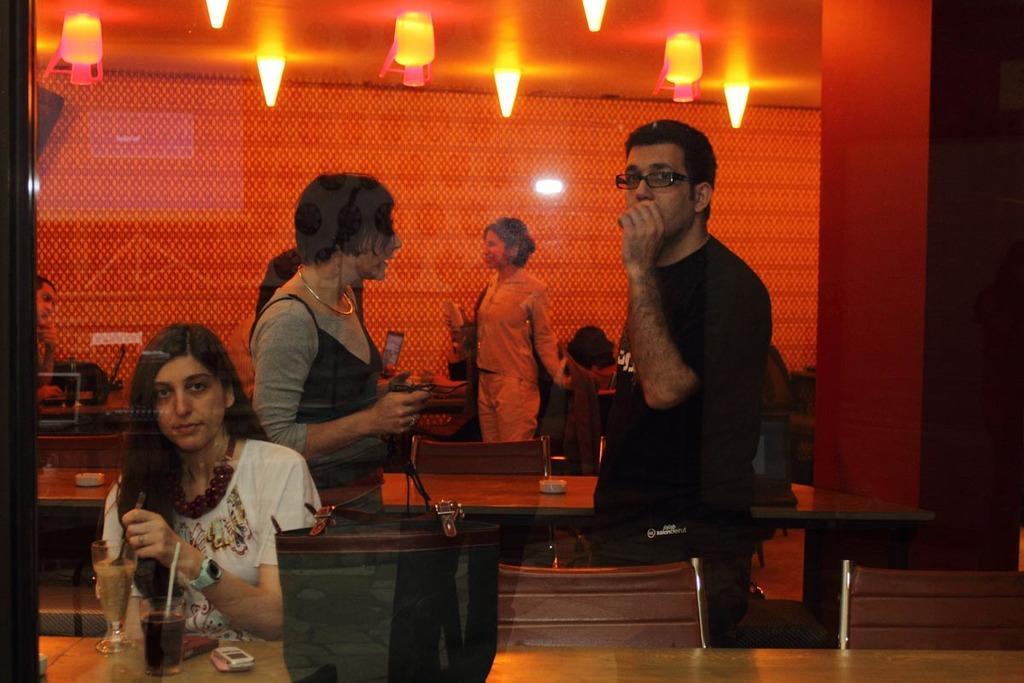Please provide a concise description of this image. This image is taken in a restaurant. In this image we can see a man and a woman standing. We can also see a woman sitting on the chair in front of the table and on the table we can see the glasses and also mobile phone and bag. In the background we can see the chairs, tables, laptop, bag and also some persons. We can also see the wall. At the top we can see the lights and also the ceiling. 